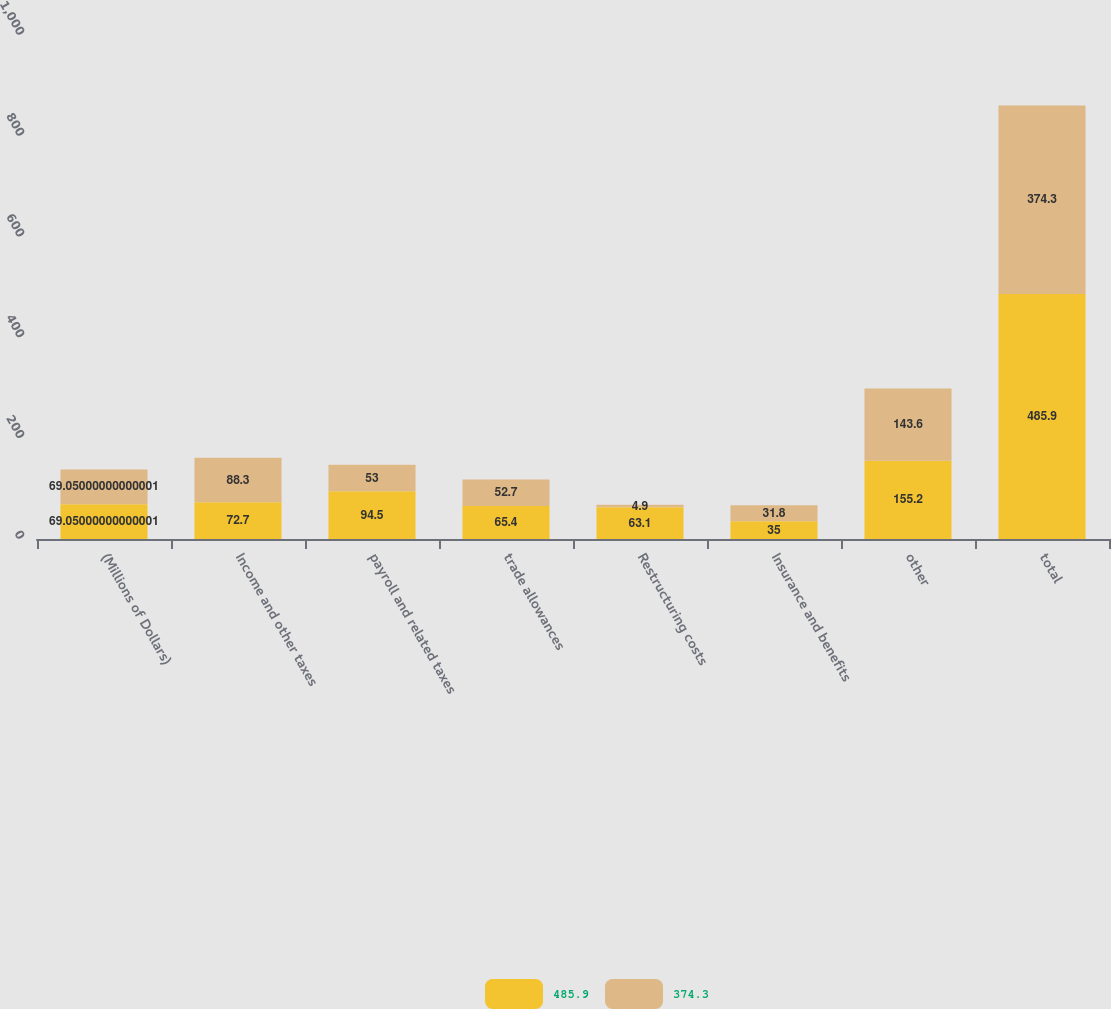Convert chart to OTSL. <chart><loc_0><loc_0><loc_500><loc_500><stacked_bar_chart><ecel><fcel>(Millions of Dollars)<fcel>Income and other taxes<fcel>payroll and related taxes<fcel>trade allowances<fcel>Restructuring costs<fcel>Insurance and benefits<fcel>other<fcel>total<nl><fcel>485.9<fcel>69.05<fcel>72.7<fcel>94.5<fcel>65.4<fcel>63.1<fcel>35<fcel>155.2<fcel>485.9<nl><fcel>374.3<fcel>69.05<fcel>88.3<fcel>53<fcel>52.7<fcel>4.9<fcel>31.8<fcel>143.6<fcel>374.3<nl></chart> 